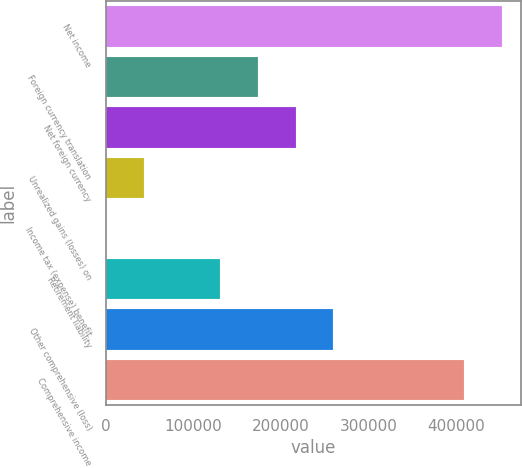Convert chart to OTSL. <chart><loc_0><loc_0><loc_500><loc_500><bar_chart><fcel>Net income<fcel>Foreign currency translation<fcel>Net foreign currency<fcel>Unrealized gains (losses) on<fcel>Income tax (expense) benefit<fcel>Retirement liability<fcel>Other comprehensive (loss)<fcel>Comprehensive income<nl><fcel>451971<fcel>173391<fcel>216654<fcel>43601.9<fcel>339<fcel>130128<fcel>259916<fcel>408708<nl></chart> 